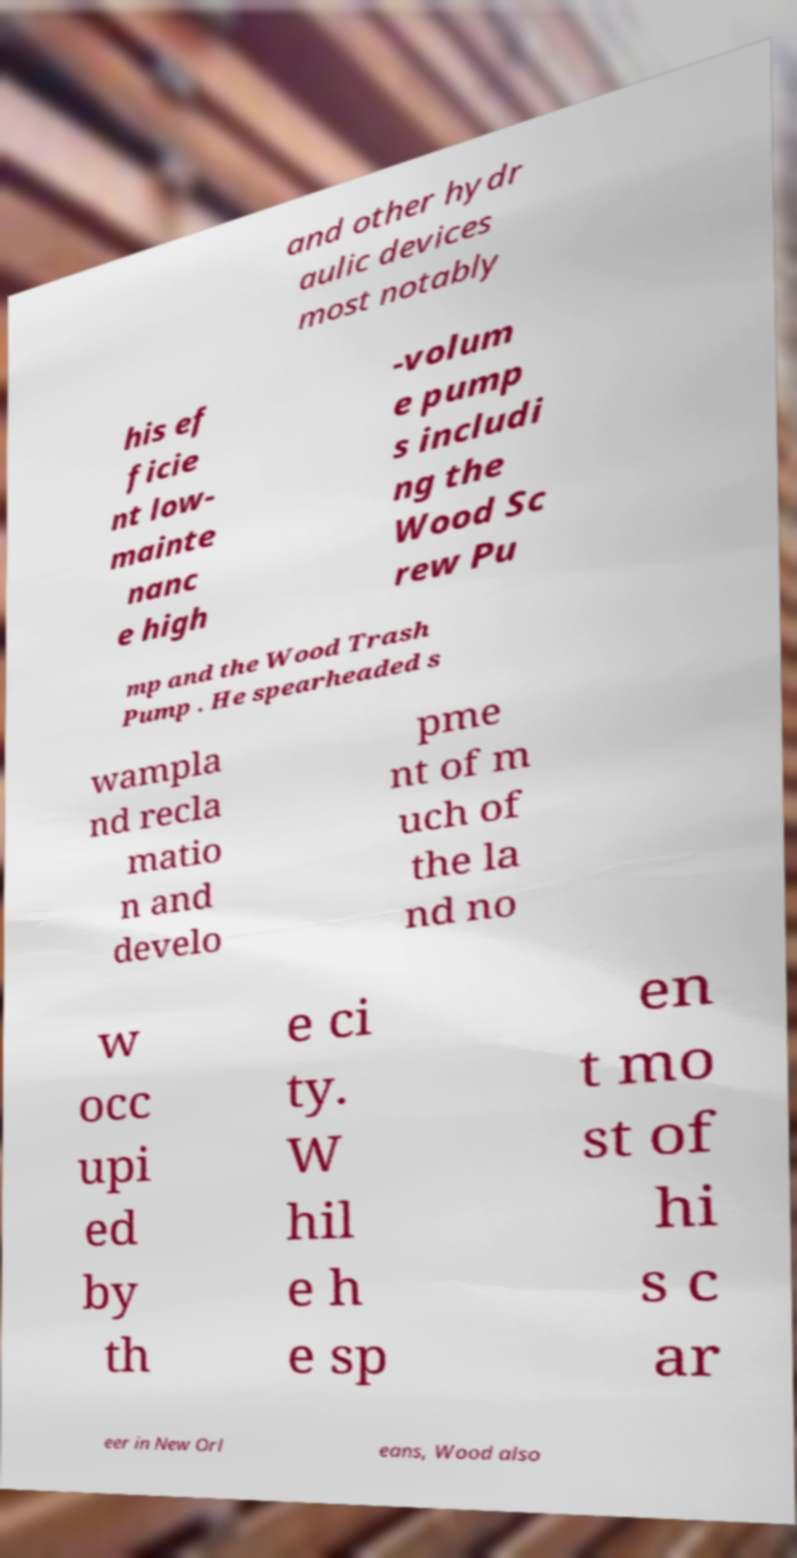Please identify and transcribe the text found in this image. and other hydr aulic devices most notably his ef ficie nt low- mainte nanc e high -volum e pump s includi ng the Wood Sc rew Pu mp and the Wood Trash Pump . He spearheaded s wampla nd recla matio n and develo pme nt of m uch of the la nd no w occ upi ed by th e ci ty. W hil e h e sp en t mo st of hi s c ar eer in New Orl eans, Wood also 